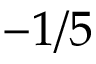Convert formula to latex. <formula><loc_0><loc_0><loc_500><loc_500>- 1 / 5</formula> 